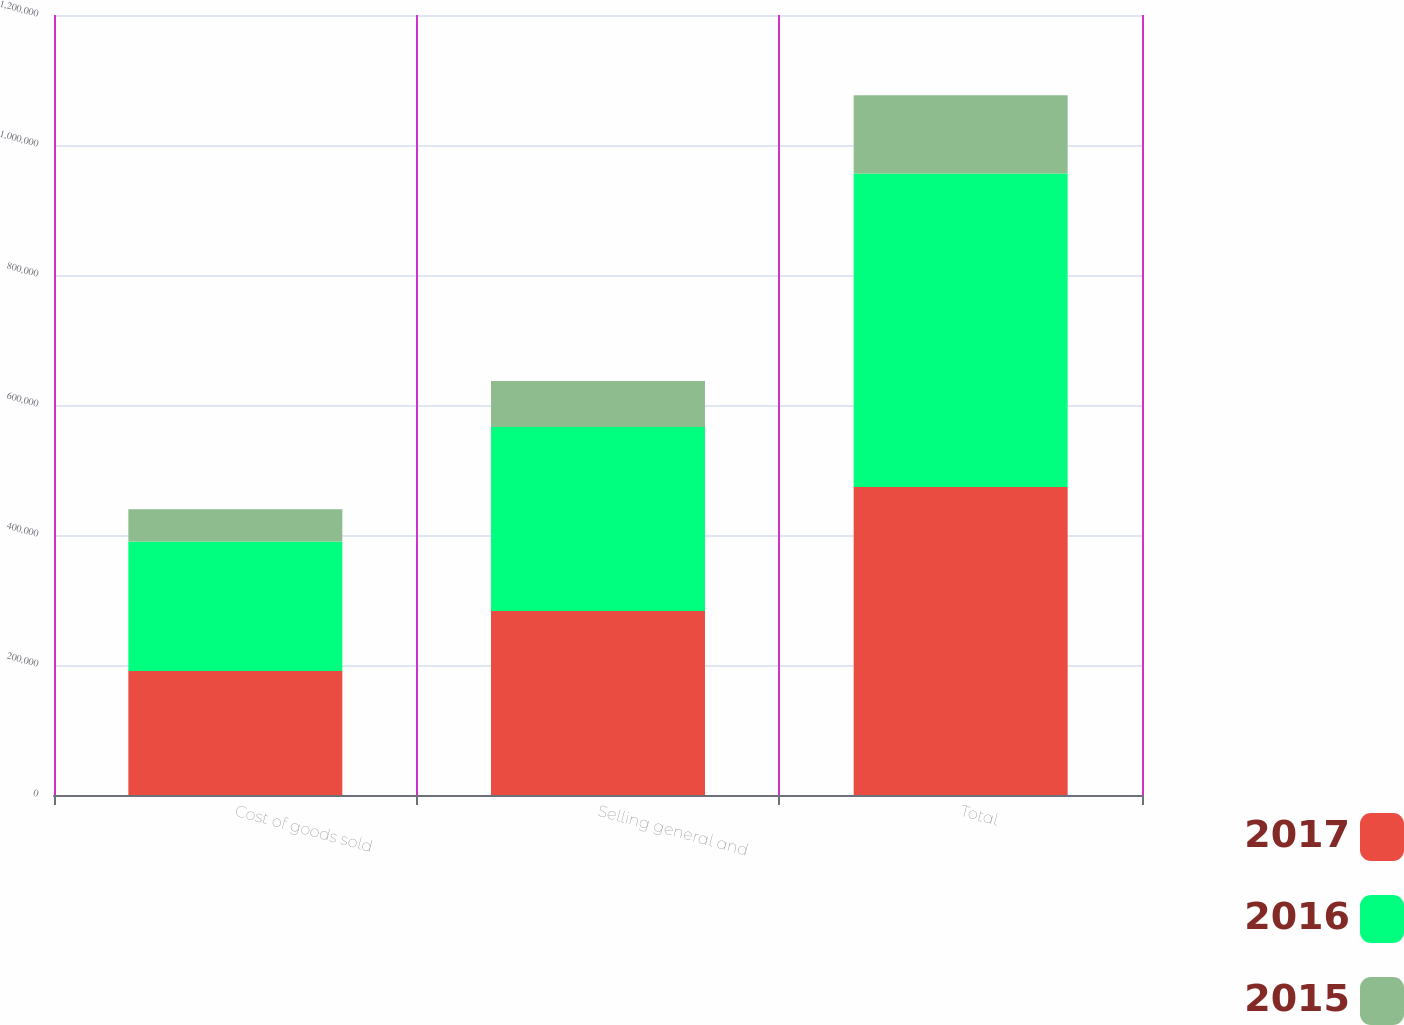<chart> <loc_0><loc_0><loc_500><loc_500><stacked_bar_chart><ecel><fcel>Cost of goods sold<fcel>Selling general and<fcel>Total<nl><fcel>2017<fcel>190792<fcel>283000<fcel>473792<nl><fcel>2016<fcel>199257<fcel>283000<fcel>482257<nl><fcel>2015<fcel>49583<fcel>70750<fcel>120333<nl></chart> 